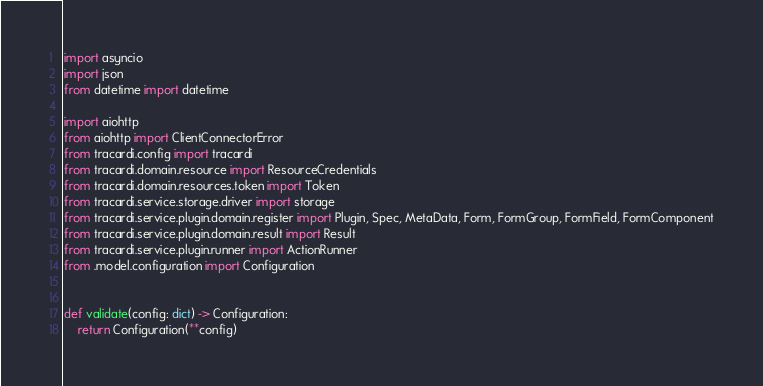<code> <loc_0><loc_0><loc_500><loc_500><_Python_>import asyncio
import json
from datetime import datetime

import aiohttp
from aiohttp import ClientConnectorError
from tracardi.config import tracardi
from tracardi.domain.resource import ResourceCredentials
from tracardi.domain.resources.token import Token
from tracardi.service.storage.driver import storage
from tracardi.service.plugin.domain.register import Plugin, Spec, MetaData, Form, FormGroup, FormField, FormComponent
from tracardi.service.plugin.domain.result import Result
from tracardi.service.plugin.runner import ActionRunner
from .model.configuration import Configuration


def validate(config: dict) -> Configuration:
    return Configuration(**config)

</code> 